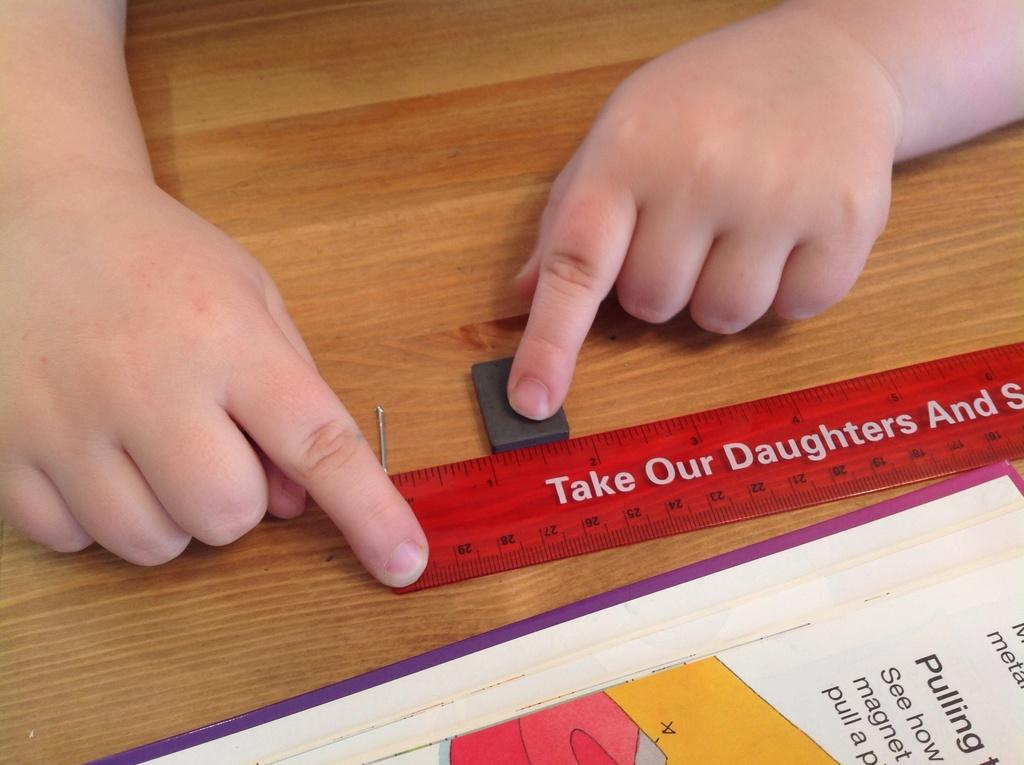<image>
Create a compact narrative representing the image presented. A red ruler is on a table that says, "Take our daughters" in white letters. 